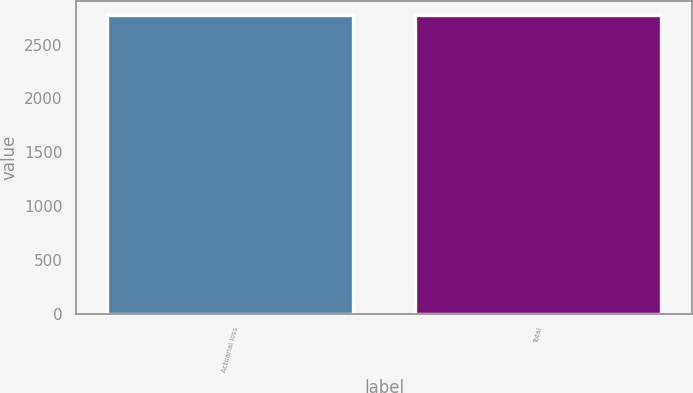Convert chart. <chart><loc_0><loc_0><loc_500><loc_500><bar_chart><fcel>Actuarial loss<fcel>Total<nl><fcel>2771<fcel>2771.1<nl></chart> 